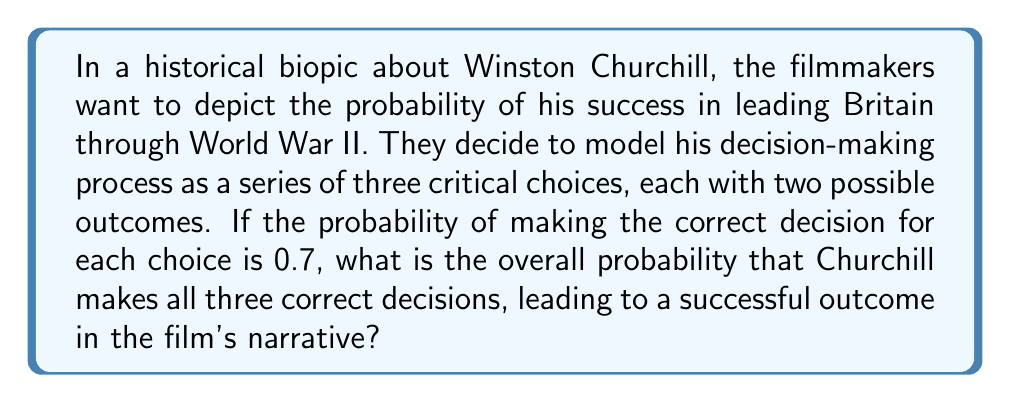Give your solution to this math problem. To solve this problem, we need to use the concept of independent events in probability theory. Each decision is considered independent of the others, and we want the probability of all three being correct.

1. Let's define our events:
   $A$: Correct decision for choice 1
   $B$: Correct decision for choice 2
   $C$: Correct decision for choice 3

2. Given:
   $P(A) = P(B) = P(C) = 0.7$

3. We want to find the probability of all three events occurring together:
   $P(A \cap B \cap C)$

4. For independent events, the probability of all events occurring is the product of their individual probabilities:
   $P(A \cap B \cap C) = P(A) \times P(B) \times P(C)$

5. Substituting the given probabilities:
   $P(A \cap B \cap C) = 0.7 \times 0.7 \times 0.7$

6. Calculating:
   $P(A \cap B \cap C) = 0.7^3 = 0.343$

Therefore, the probability of Churchill making all three correct decisions in the film's narrative is 0.343 or 34.3%.
Answer: $0.343$ or $34.3\%$ 